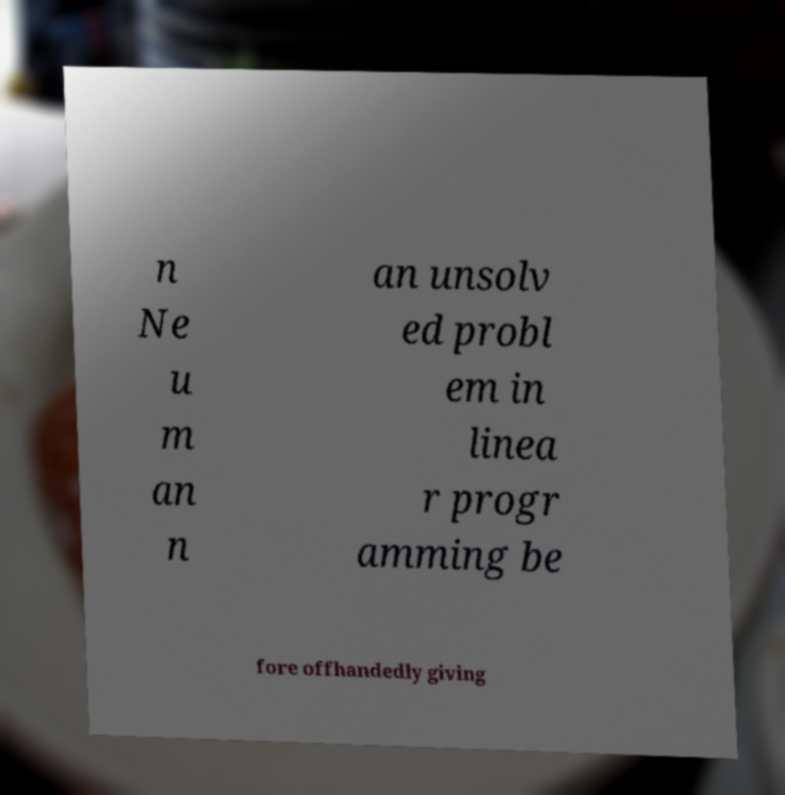There's text embedded in this image that I need extracted. Can you transcribe it verbatim? n Ne u m an n an unsolv ed probl em in linea r progr amming be fore offhandedly giving 